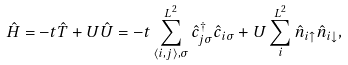Convert formula to latex. <formula><loc_0><loc_0><loc_500><loc_500>\hat { H } = - t \hat { T } + U \hat { U } = - t \sum _ { \langle i , j \rangle , \sigma } ^ { L ^ { 2 } } \hat { c } ^ { \dagger } _ { j \sigma } \hat { c } _ { i \sigma } + U \sum _ { i } ^ { L ^ { 2 } } \hat { n } _ { i \uparrow } \hat { n } _ { i \downarrow } ,</formula> 